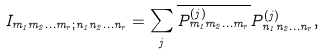<formula> <loc_0><loc_0><loc_500><loc_500>I _ { m _ { 1 } m _ { 2 } \dots m _ { r } ; n _ { 1 } n _ { 2 } \dots n _ { r } } = \sum _ { j } \overline { P ^ { ( j ) } _ { m _ { 1 } m _ { 2 } \dots m _ { r } } } P ^ { ( j ) } _ { n _ { 1 } n _ { 2 } \dots n _ { r } } ,</formula> 